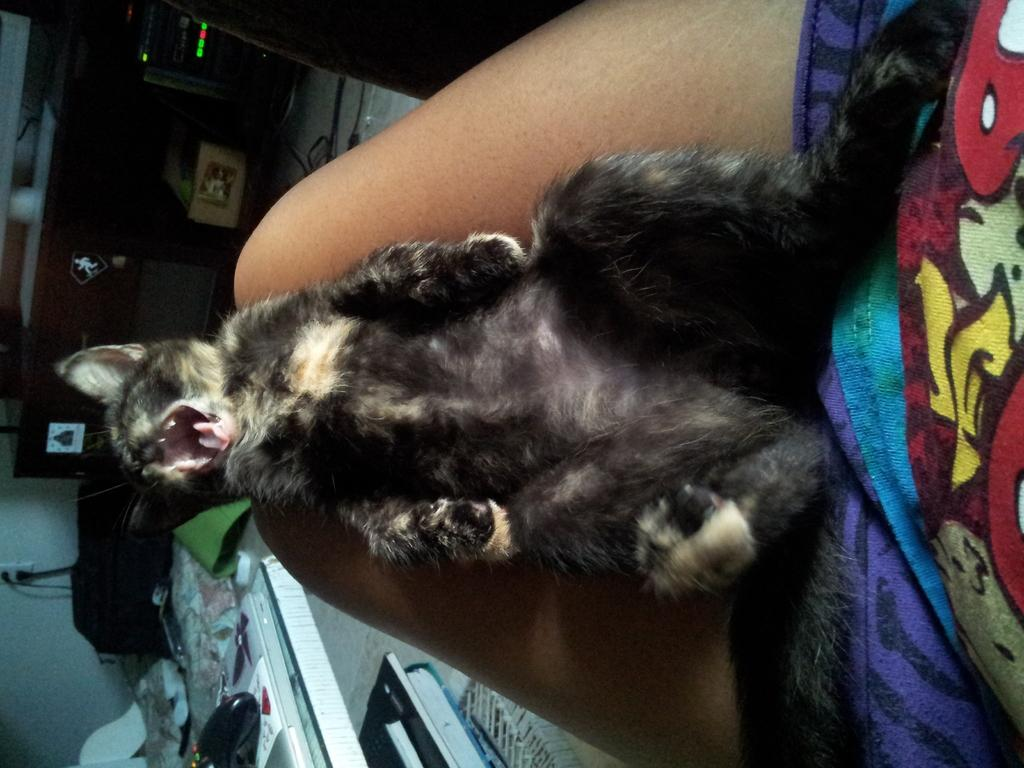What type of animal is in the image? There is a cat in the image. Where is the cat located in relation to the person? The cat is lying on the lap of a person. What can be seen in the background of the image? There are books, a table, and a socket visible in the background of the image. Can you describe any other items visible in the background? There are other items visible in the background of the image, but their specific details are not mentioned in the provided facts. What type of zipper can be seen on the cat's fur in the image? There is no zipper present on the cat's fur in the image. What type of town is visible in the background of the image? There is no town visible in the background of the image; it only shows a cat, a person, and various items in the background. 